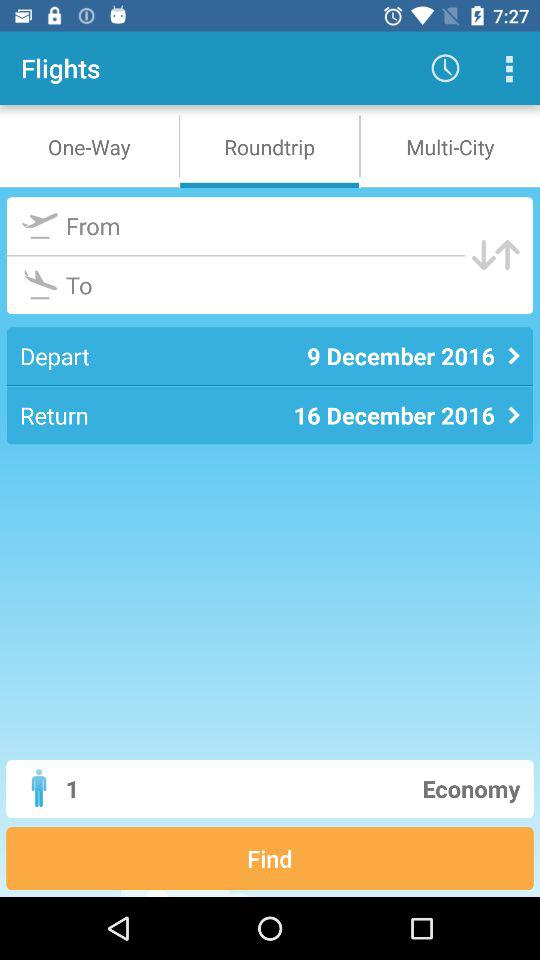How many people are in this booking?
Answer the question using a single word or phrase. 1 